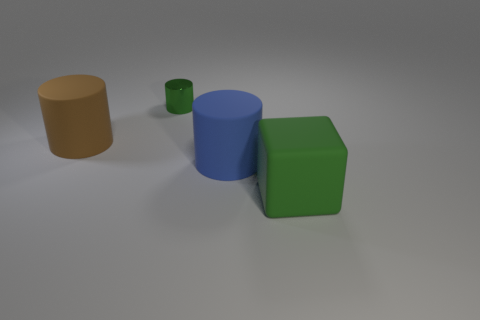Is there anything else that is made of the same material as the green cylinder?
Offer a terse response. No. Are there any other things that are the same size as the green shiny thing?
Your answer should be compact. No. Are there any other things that have the same color as the shiny cylinder?
Your response must be concise. Yes. How many green metallic cylinders are left of the green rubber cube?
Keep it short and to the point. 1. Are the green object that is on the left side of the large green object and the large brown thing made of the same material?
Ensure brevity in your answer.  No. What number of other big rubber objects are the same shape as the blue object?
Offer a terse response. 1. What number of small things are either brown matte cylinders or green metal objects?
Your answer should be compact. 1. There is a large cylinder in front of the brown rubber cylinder; is its color the same as the metallic cylinder?
Give a very brief answer. No. There is a large object on the left side of the tiny metal cylinder; is it the same color as the big matte cylinder on the right side of the large brown rubber thing?
Your answer should be very brief. No. Is there a big cyan ball that has the same material as the big brown cylinder?
Your answer should be very brief. No. 